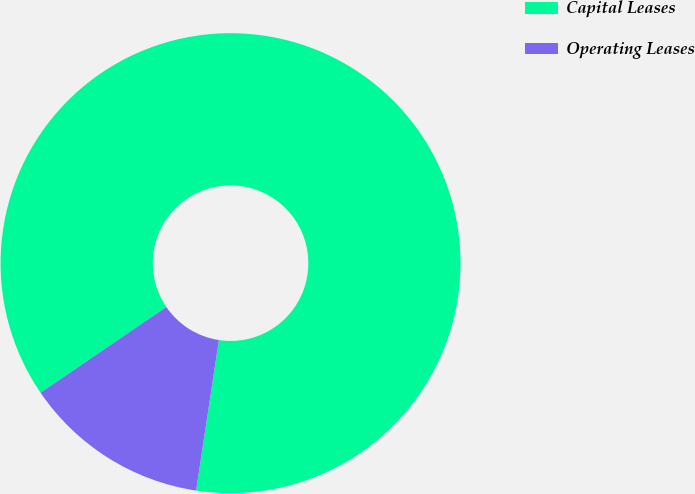Convert chart to OTSL. <chart><loc_0><loc_0><loc_500><loc_500><pie_chart><fcel>Capital Leases<fcel>Operating Leases<nl><fcel>86.92%<fcel>13.08%<nl></chart> 